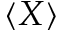<formula> <loc_0><loc_0><loc_500><loc_500>\langle X \rangle</formula> 